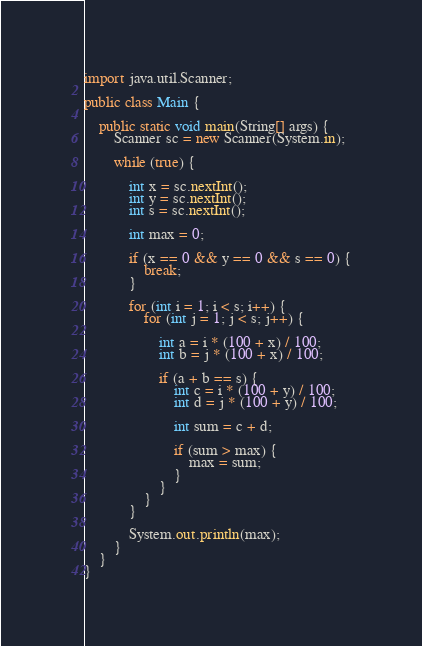<code> <loc_0><loc_0><loc_500><loc_500><_Java_>

import java.util.Scanner;

public class Main {

	public static void main(String[] args) {
		Scanner sc = new Scanner(System.in);

		while (true) {

			int x = sc.nextInt();
			int y = sc.nextInt();
			int s = sc.nextInt();

			int max = 0;

			if (x == 0 && y == 0 && s == 0) {
				break;
			}

			for (int i = 1; i < s; i++) {
				for (int j = 1; j < s; j++) {

					int a = i * (100 + x) / 100;
					int b = j * (100 + x) / 100;

					if (a + b == s) {
						int c = i * (100 + y) / 100;
						int d = j * (100 + y) / 100;

						int sum = c + d;

						if (sum > max) {
							max = sum;
						}
					}
				}
			}

			System.out.println(max);
		}
	}
}</code> 